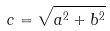<formula> <loc_0><loc_0><loc_500><loc_500>c = \sqrt { a ^ { 2 } + b ^ { 2 } }</formula> 